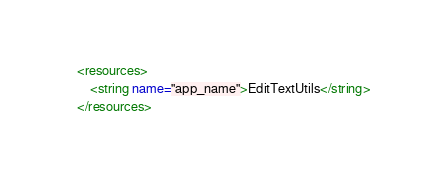<code> <loc_0><loc_0><loc_500><loc_500><_XML_><resources>
    <string name="app_name">EditTextUtils</string>
</resources>
</code> 